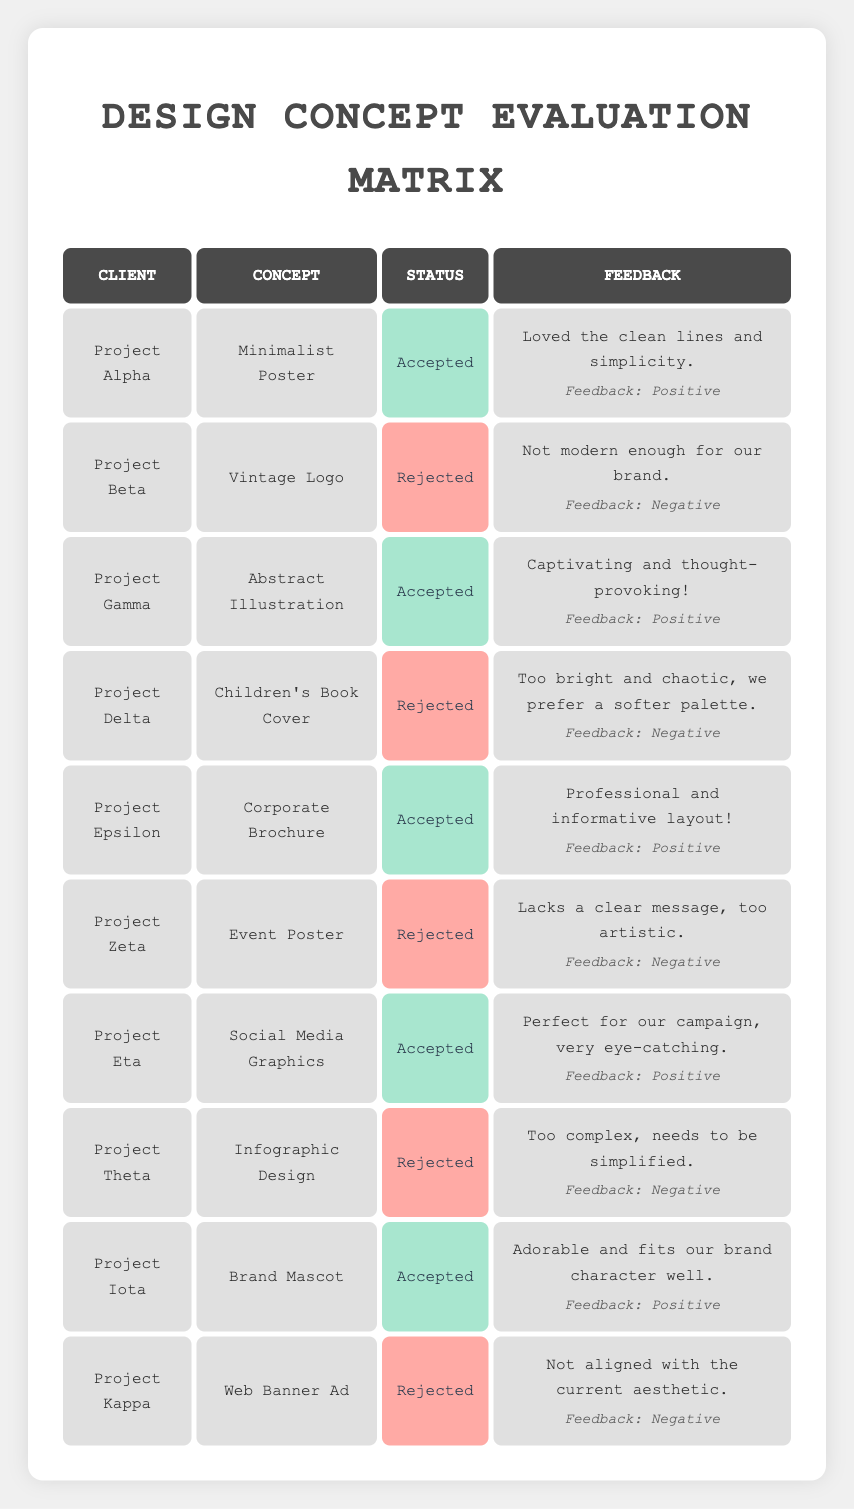What is the total number of design concepts that were accepted by clients? There are 5 accepted design concepts in the table: Minimalist Poster, Abstract Illustration, Corporate Brochure, Social Media Graphics, and Brand Mascot.
Answer: 5 What is the name of the client who rejected the Vintage Logo concept? The client who rejected the Vintage Logo concept is Project Beta.
Answer: Project Beta Which design concept received positive feedback for being "professional and informative"? The feedback for the Corporate Brochure states it was "Professional and informative layout!" indicating it received positive feedback for that concept.
Answer: Corporate Brochure How many concepts were rejected due to aesthetic misalignment or complexity? There are 3 rejected concepts: Vintage Logo (not modern enough), Infographic Design (too complex), and Web Banner Ad (not aligned with the current aesthetic), totaling 3 concepts.
Answer: 3 What percentage of the design concepts submitted were accepted by clients? Out of 10 total design concepts, 5 were accepted. Therefore, the percentage is (5 accepted / 10 total) * 100 = 50%.
Answer: 50% Were any design concepts rejected because they were too colorful or busy? Yes, the Children's Book Cover was rejected because it was described as "Too bright and chaotic."
Answer: Yes Can you identify a design concept that was accepted with feedback mentioning it was "eye-catching"? The Social Media Graphics concept received feedback stating it was "Perfect for our campaign, very eye-catching."
Answer: Social Media Graphics How many clients provided the feedback regarding the simplicity of their accepted design concepts? Two clients provided feedback regarding simplicity: Project Alpha stated the Minimalist Poster had "clean lines and simplicity," and Project Theta was rejected for being "complex." However, only Alpha provided positive feedback on simplicity, while Theta was noted for being too complex.
Answer: 1 client What is the difference between the number of accepted and rejected concepts? There are 5 accepted concepts and 5 rejected concepts, thus the difference is 5 - 5 = 0.
Answer: 0 Which rejected concept was deemed too artistic for its intended purpose? The Event Poster concept was considered too artistic, as the feedback indicated it "lacks a clear message."
Answer: Event Poster 